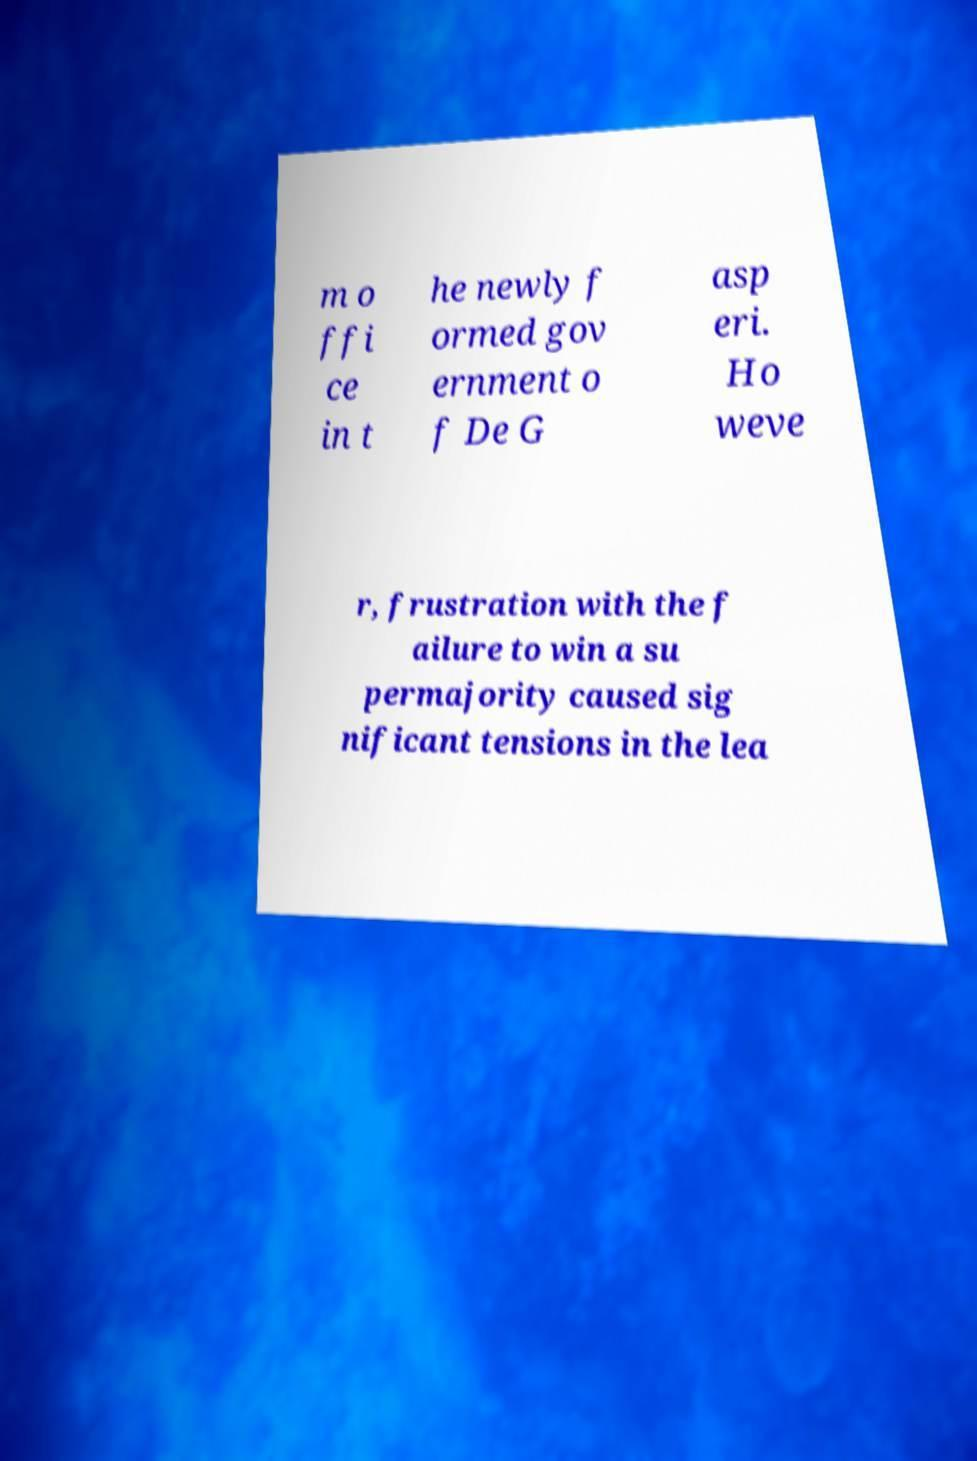Please read and relay the text visible in this image. What does it say? m o ffi ce in t he newly f ormed gov ernment o f De G asp eri. Ho weve r, frustration with the f ailure to win a su permajority caused sig nificant tensions in the lea 